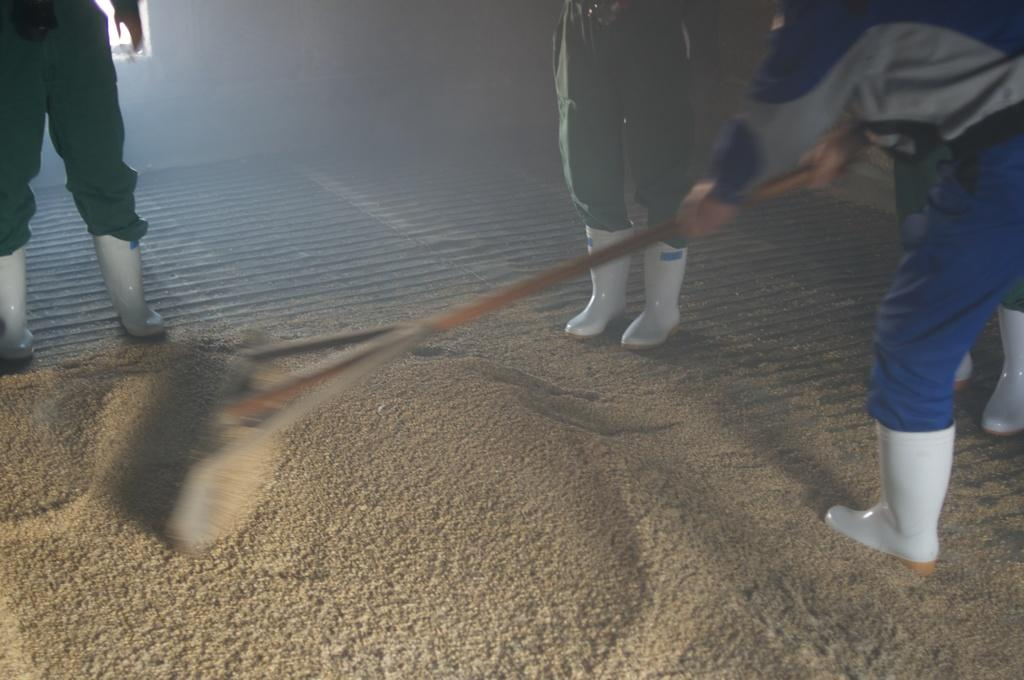How many people are in the image? There are three persons in the image. What are the persons wearing? The persons are wearing dresses. What is one person holding in their hand? One person is holding a stick in their hand. What can be seen in the background of the image? There is a window visible in the background of the image. Can you tell me how many beetles are crawling on the wall in the image? There are no beetles or walls present in the image; it features three persons wearing dresses, one of whom is holding a stick, and a window visible in the background. 